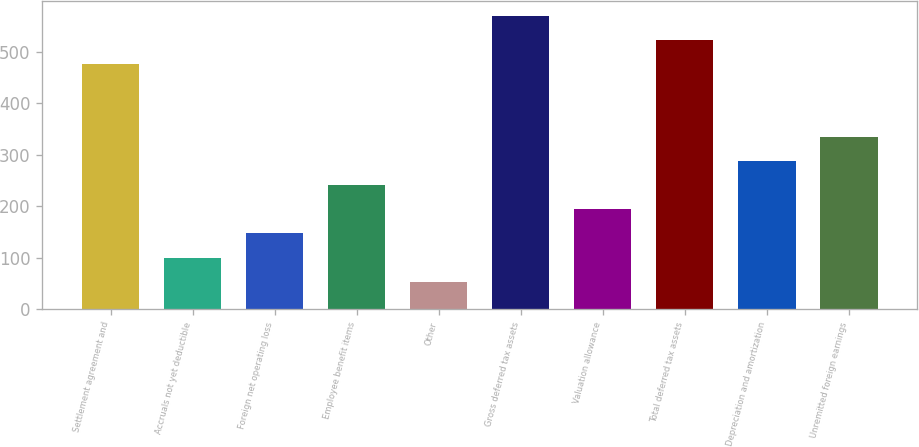Convert chart to OTSL. <chart><loc_0><loc_0><loc_500><loc_500><bar_chart><fcel>Settlement agreement and<fcel>Accruals not yet deductible<fcel>Foreign net operating loss<fcel>Employee benefit items<fcel>Other<fcel>Gross deferred tax assets<fcel>Valuation allowance<fcel>Total deferred tax assets<fcel>Depreciation and amortization<fcel>Unremitted foreign earnings<nl><fcel>476.3<fcel>100.14<fcel>147.16<fcel>241.2<fcel>53.12<fcel>570.34<fcel>194.18<fcel>523.32<fcel>288.22<fcel>335.24<nl></chart> 